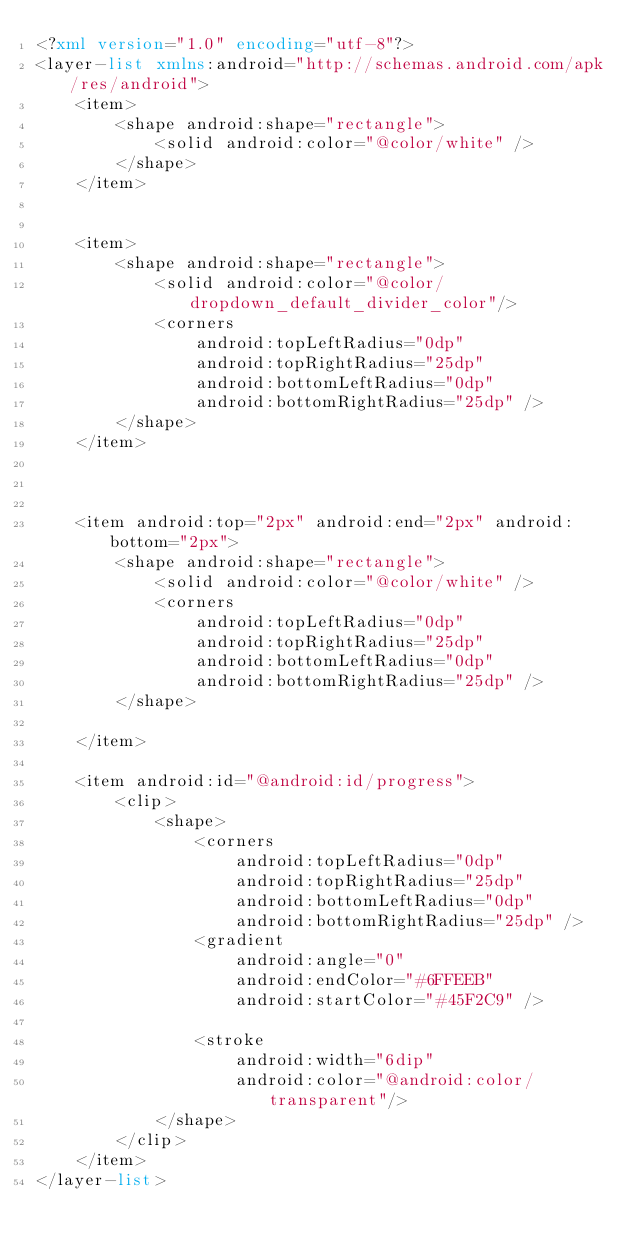Convert code to text. <code><loc_0><loc_0><loc_500><loc_500><_XML_><?xml version="1.0" encoding="utf-8"?>
<layer-list xmlns:android="http://schemas.android.com/apk/res/android">
    <item>
        <shape android:shape="rectangle">
            <solid android:color="@color/white" />
        </shape>
    </item>


    <item>
        <shape android:shape="rectangle">
            <solid android:color="@color/dropdown_default_divider_color"/>
            <corners
                android:topLeftRadius="0dp"
                android:topRightRadius="25dp"
                android:bottomLeftRadius="0dp"
                android:bottomRightRadius="25dp" />
        </shape>
    </item>



    <item android:top="2px" android:end="2px" android:bottom="2px">
        <shape android:shape="rectangle">
            <solid android:color="@color/white" />
            <corners
                android:topLeftRadius="0dp"
                android:topRightRadius="25dp"
                android:bottomLeftRadius="0dp"
                android:bottomRightRadius="25dp" />
        </shape>

    </item>

    <item android:id="@android:id/progress">
        <clip>
            <shape>
                <corners
                    android:topLeftRadius="0dp"
                    android:topRightRadius="25dp"
                    android:bottomLeftRadius="0dp"
                    android:bottomRightRadius="25dp" />
                <gradient
                    android:angle="0"
                    android:endColor="#6FFEEB"
                    android:startColor="#45F2C9" />

                <stroke
                    android:width="6dip"
                    android:color="@android:color/transparent"/>
            </shape>
        </clip>
    </item>
</layer-list></code> 